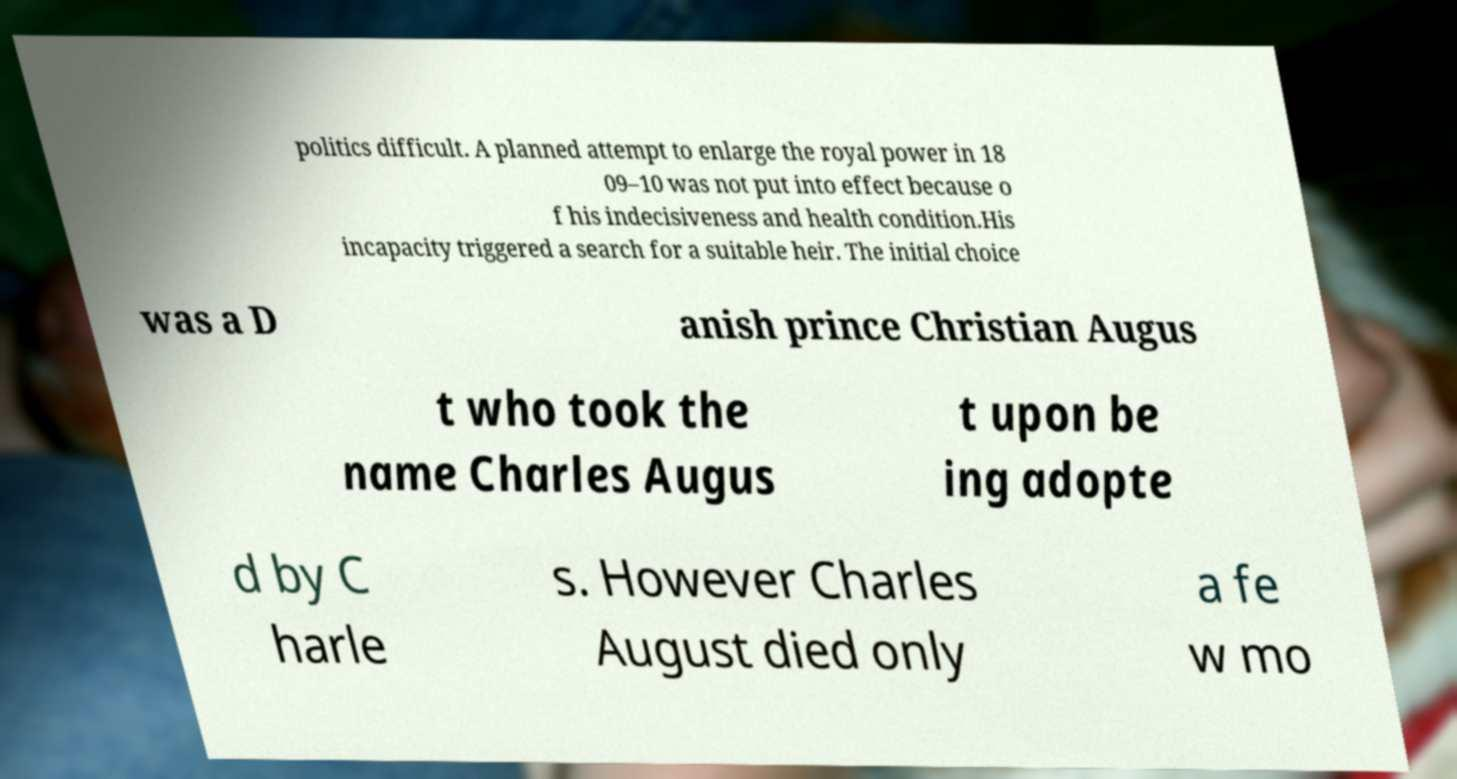I need the written content from this picture converted into text. Can you do that? politics difficult. A planned attempt to enlarge the royal power in 18 09–10 was not put into effect because o f his indecisiveness and health condition.His incapacity triggered a search for a suitable heir. The initial choice was a D anish prince Christian Augus t who took the name Charles Augus t upon be ing adopte d by C harle s. However Charles August died only a fe w mo 